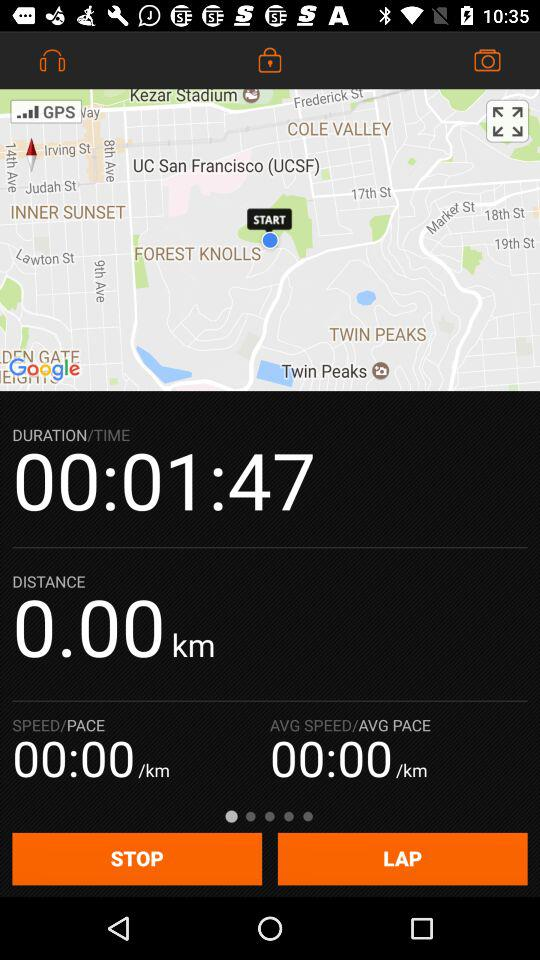What is the duration of the activity?
Answer the question using a single word or phrase. 00:01:47 